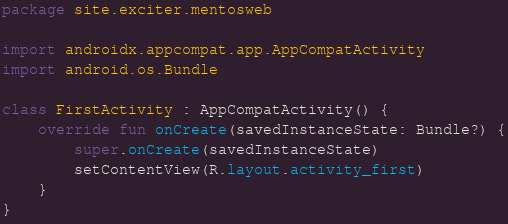<code> <loc_0><loc_0><loc_500><loc_500><_Kotlin_>package site.exciter.mentosweb

import androidx.appcompat.app.AppCompatActivity
import android.os.Bundle

class FirstActivity : AppCompatActivity() {
    override fun onCreate(savedInstanceState: Bundle?) {
        super.onCreate(savedInstanceState)
        setContentView(R.layout.activity_first)
    }
}</code> 